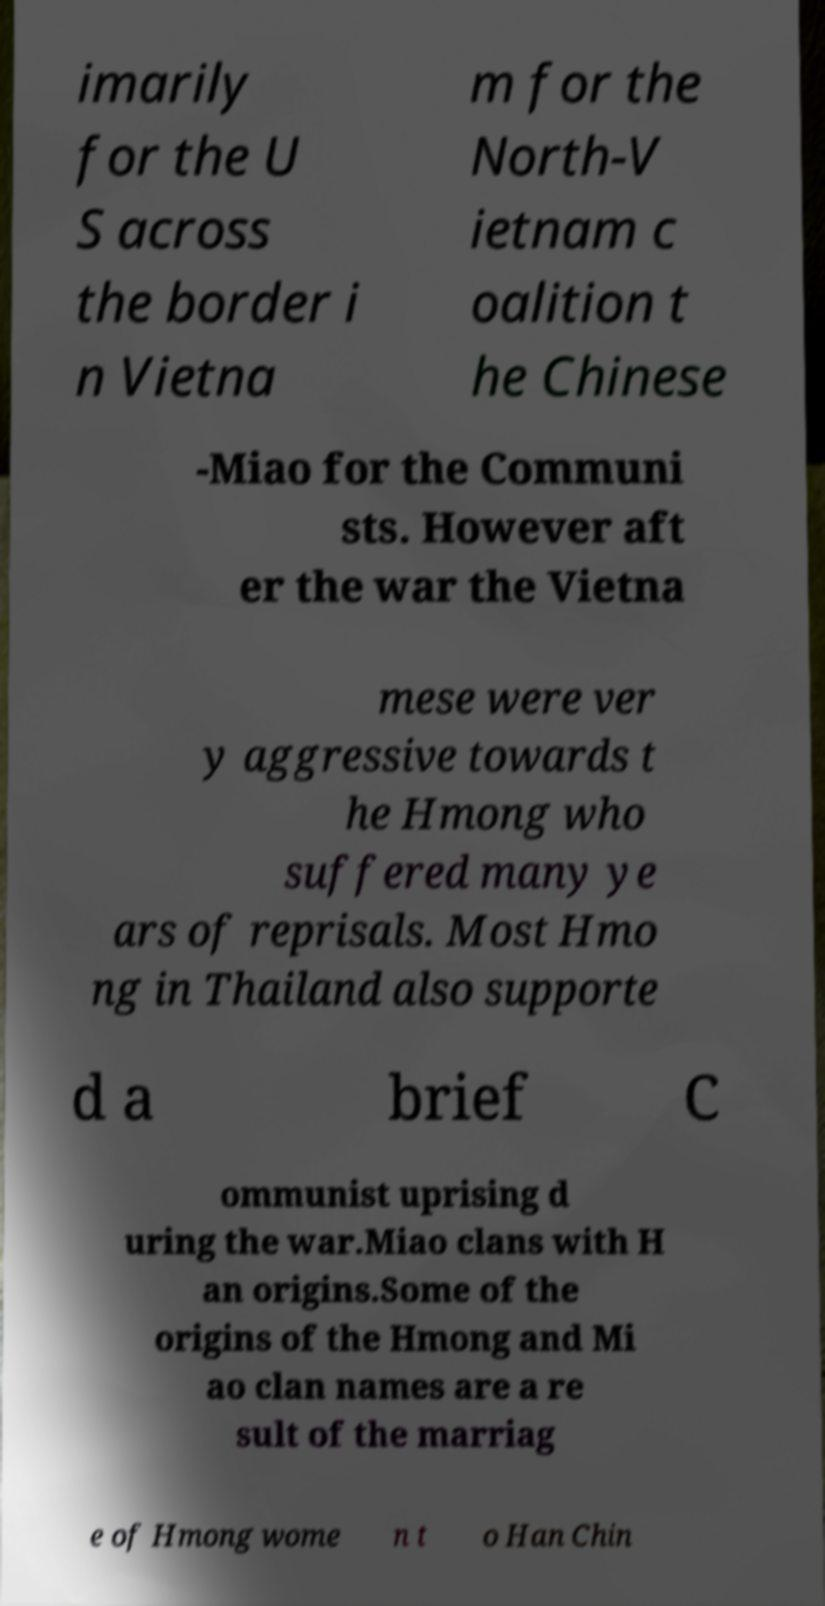There's text embedded in this image that I need extracted. Can you transcribe it verbatim? imarily for the U S across the border i n Vietna m for the North-V ietnam c oalition t he Chinese -Miao for the Communi sts. However aft er the war the Vietna mese were ver y aggressive towards t he Hmong who suffered many ye ars of reprisals. Most Hmo ng in Thailand also supporte d a brief C ommunist uprising d uring the war.Miao clans with H an origins.Some of the origins of the Hmong and Mi ao clan names are a re sult of the marriag e of Hmong wome n t o Han Chin 